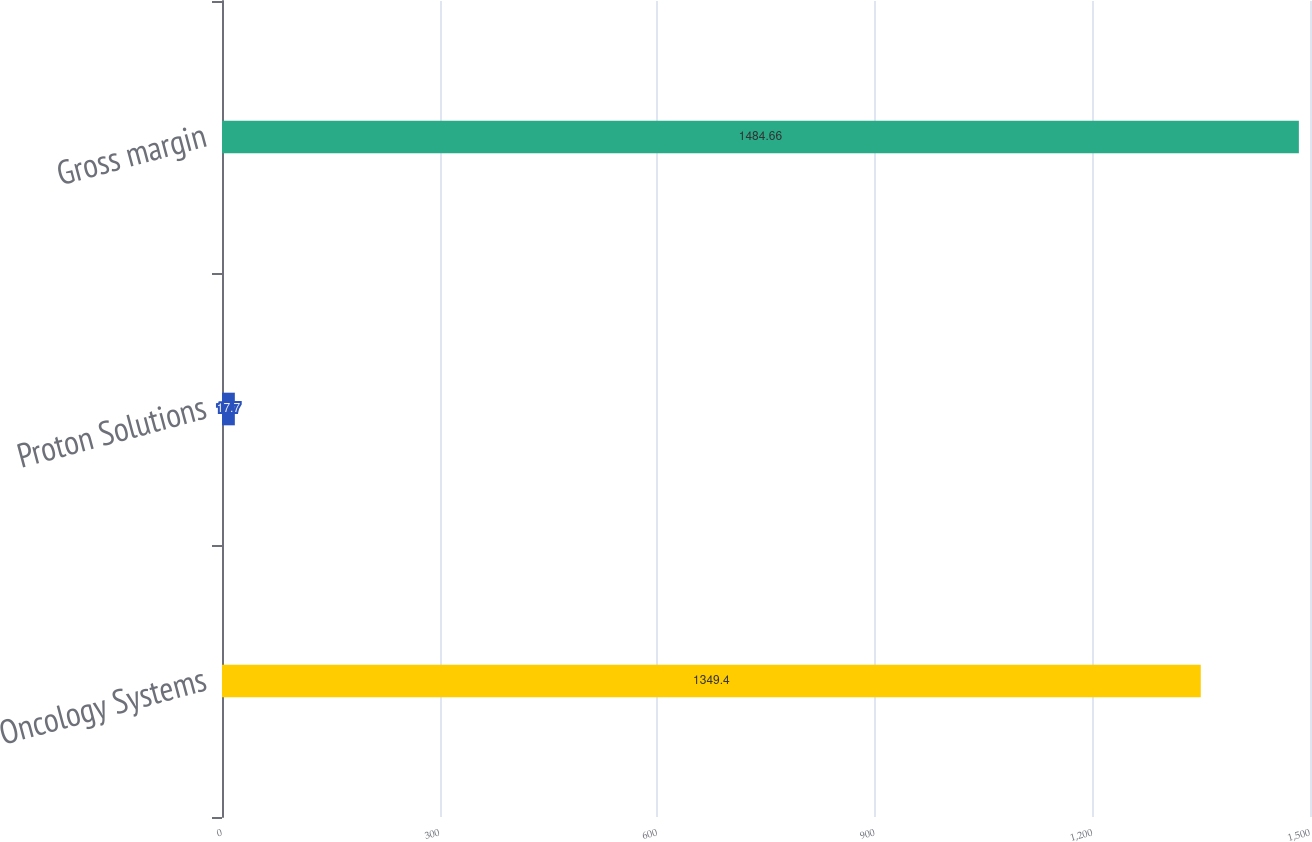<chart> <loc_0><loc_0><loc_500><loc_500><bar_chart><fcel>Oncology Systems<fcel>Proton Solutions<fcel>Gross margin<nl><fcel>1349.4<fcel>17.7<fcel>1484.66<nl></chart> 